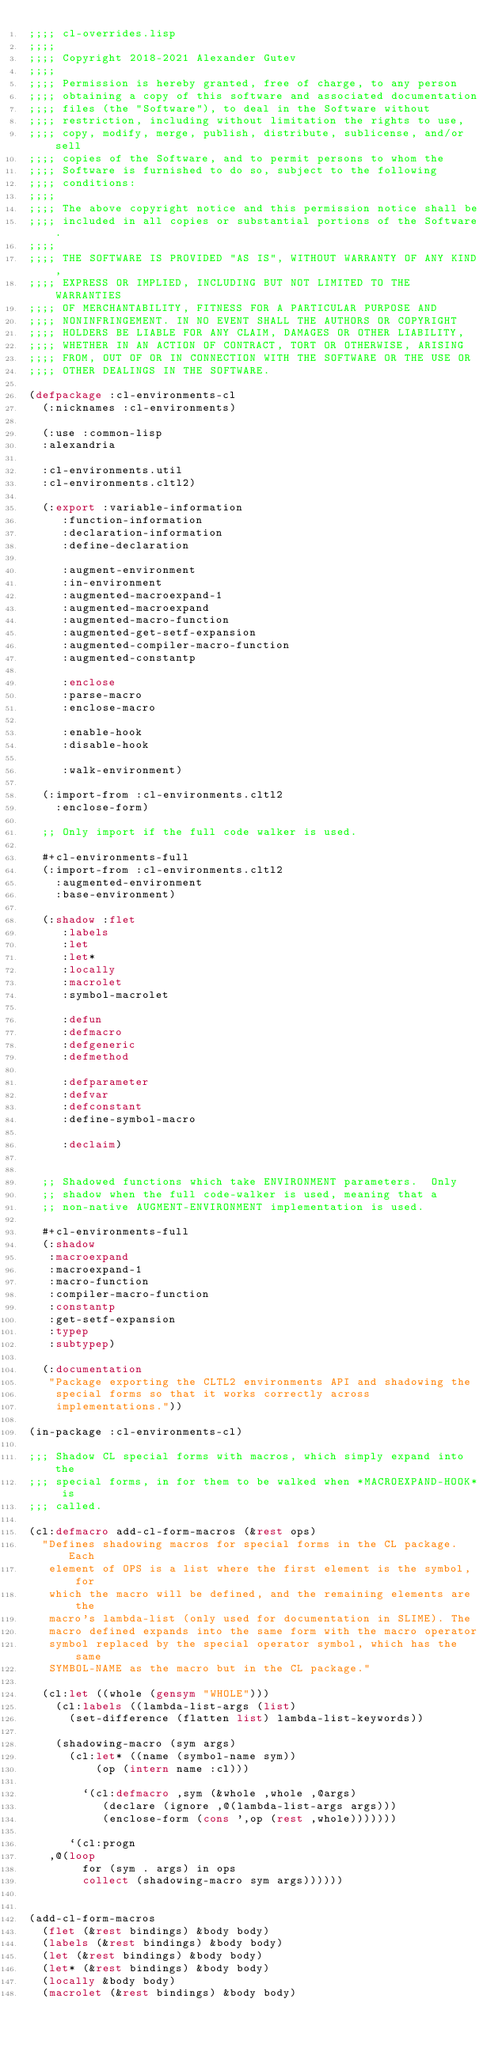<code> <loc_0><loc_0><loc_500><loc_500><_Lisp_>;;;; cl-overrides.lisp
;;;;
;;;; Copyright 2018-2021 Alexander Gutev
;;;;
;;;; Permission is hereby granted, free of charge, to any person
;;;; obtaining a copy of this software and associated documentation
;;;; files (the "Software"), to deal in the Software without
;;;; restriction, including without limitation the rights to use,
;;;; copy, modify, merge, publish, distribute, sublicense, and/or sell
;;;; copies of the Software, and to permit persons to whom the
;;;; Software is furnished to do so, subject to the following
;;;; conditions:
;;;;
;;;; The above copyright notice and this permission notice shall be
;;;; included in all copies or substantial portions of the Software.
;;;;
;;;; THE SOFTWARE IS PROVIDED "AS IS", WITHOUT WARRANTY OF ANY KIND,
;;;; EXPRESS OR IMPLIED, INCLUDING BUT NOT LIMITED TO THE WARRANTIES
;;;; OF MERCHANTABILITY, FITNESS FOR A PARTICULAR PURPOSE AND
;;;; NONINFRINGEMENT. IN NO EVENT SHALL THE AUTHORS OR COPYRIGHT
;;;; HOLDERS BE LIABLE FOR ANY CLAIM, DAMAGES OR OTHER LIABILITY,
;;;; WHETHER IN AN ACTION OF CONTRACT, TORT OR OTHERWISE, ARISING
;;;; FROM, OUT OF OR IN CONNECTION WITH THE SOFTWARE OR THE USE OR
;;;; OTHER DEALINGS IN THE SOFTWARE.

(defpackage :cl-environments-cl
  (:nicknames :cl-environments)

  (:use :common-lisp
	:alexandria

	:cl-environments.util
	:cl-environments.cltl2)

  (:export :variable-information
	   :function-information
	   :declaration-information
	   :define-declaration

	   :augment-environment
	   :in-environment
	   :augmented-macroexpand-1
	   :augmented-macroexpand
	   :augmented-macro-function
	   :augmented-get-setf-expansion
	   :augmented-compiler-macro-function
	   :augmented-constantp

	   :enclose
	   :parse-macro
	   :enclose-macro

	   :enable-hook
	   :disable-hook

	   :walk-environment)

  (:import-from :cl-environments.cltl2
		:enclose-form)

  ;; Only import if the full code walker is used.

  #+cl-environments-full
  (:import-from :cl-environments.cltl2
		:augmented-environment
		:base-environment)

  (:shadow :flet
	   :labels
	   :let
	   :let*
	   :locally
	   :macrolet
	   :symbol-macrolet

	   :defun
	   :defmacro
	   :defgeneric
	   :defmethod

	   :defparameter
	   :defvar
	   :defconstant
	   :define-symbol-macro

	   :declaim)


  ;; Shadowed functions which take ENVIRONMENT parameters.  Only
  ;; shadow when the full code-walker is used, meaning that a
  ;; non-native AUGMENT-ENVIRONMENT implementation is used.

  #+cl-environments-full
  (:shadow
   :macroexpand
   :macroexpand-1
   :macro-function
   :compiler-macro-function
   :constantp
   :get-setf-expansion
   :typep
   :subtypep)

  (:documentation
   "Package exporting the CLTL2 environments API and shadowing the
    special forms so that it works correctly across
    implementations."))

(in-package :cl-environments-cl)

;;; Shadow CL special forms with macros, which simply expand into the
;;; special forms, in for them to be walked when *MACROEXPAND-HOOK* is
;;; called.

(cl:defmacro add-cl-form-macros (&rest ops)
  "Defines shadowing macros for special forms in the CL package. Each
   element of OPS is a list where the first element is the symbol, for
   which the macro will be defined, and the remaining elements are the
   macro's lambda-list (only used for documentation in SLIME). The
   macro defined expands into the same form with the macro operator
   symbol replaced by the special operator symbol, which has the same
   SYMBOL-NAME as the macro but in the CL package."

  (cl:let ((whole (gensym "WHOLE")))
    (cl:labels ((lambda-list-args (list)
		  (set-difference (flatten list) lambda-list-keywords))

		(shadowing-macro (sym args)
		  (cl:let* ((name (symbol-name sym))
			    (op (intern name :cl)))

		    `(cl:defmacro ,sym (&whole ,whole ,@args)
		       (declare (ignore ,@(lambda-list-args args)))
		       (enclose-form (cons ',op (rest ,whole)))))))

      `(cl:progn
	 ,@(loop
	      for (sym . args) in ops
	      collect (shadowing-macro sym args))))))


(add-cl-form-macros
  (flet (&rest bindings) &body body)
  (labels (&rest bindings) &body body)
  (let (&rest bindings) &body body)
  (let* (&rest bindings) &body body)
  (locally &body body)
  (macrolet (&rest bindings) &body body)</code> 